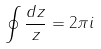Convert formula to latex. <formula><loc_0><loc_0><loc_500><loc_500>\oint \frac { d z } { z } = 2 \pi i</formula> 